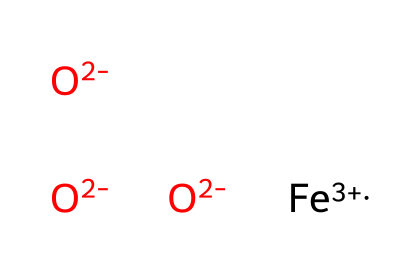What is the oxidation state of iron in this compound? The SMILES representation indicates [Fe+3], which shows that the oxidation state of iron is +3.
Answer: +3 How many oxide ions are present in this chemical structure? The notation [O-2] appears three times in the SMILES, indicating three oxide ions are present in the structure.
Answer: 3 What type of coordination compound is represented here? The presence of multiple oxide ions coordinated to a metal (iron) indicates that this is a coordination compound.
Answer: coordination compound What is the charge of the oxide ions in this structure? Each oxide ion is represented as [O-2], indicating that each oxide has a charge of -2.
Answer: -2 How does the structure contribute to the color stability of the pigments? The iron's +3 oxidation state and the presence of multiple oxide ions suggest that this structure forms a stable coordination complex, contributing to the color stability of the pigments used in dyes.
Answer: stable coordination complex Can this coordination compound form complex ions with other ligands? Yes, due to the coordination nature of iron and its +3 oxidation state, this compound has the potential to form complex ions with various ligands.
Answer: yes 